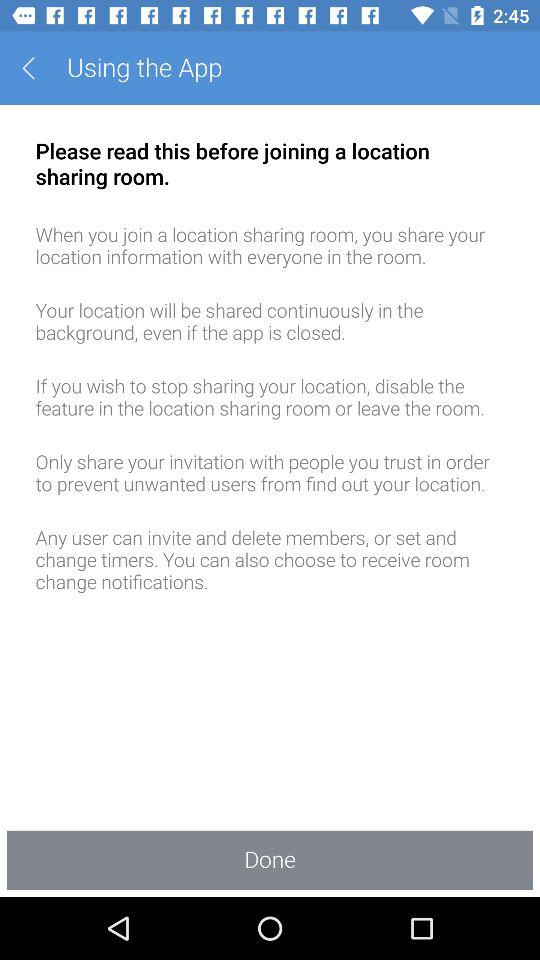With whom to share the invitation? You can share the invitation with people you trust. 